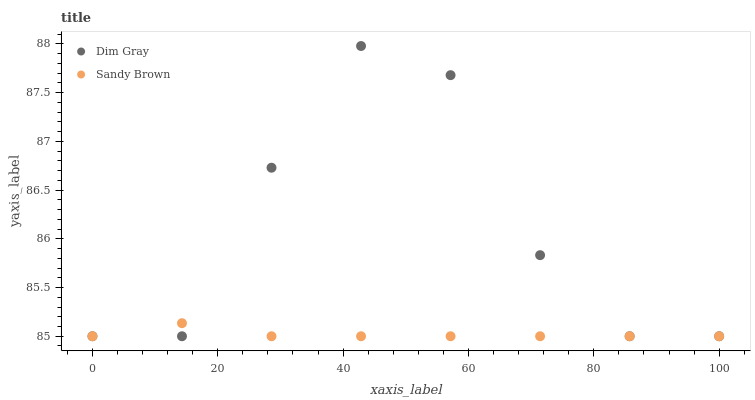Does Sandy Brown have the minimum area under the curve?
Answer yes or no. Yes. Does Dim Gray have the maximum area under the curve?
Answer yes or no. Yes. Does Sandy Brown have the maximum area under the curve?
Answer yes or no. No. Is Sandy Brown the smoothest?
Answer yes or no. Yes. Is Dim Gray the roughest?
Answer yes or no. Yes. Is Sandy Brown the roughest?
Answer yes or no. No. Does Dim Gray have the lowest value?
Answer yes or no. Yes. Does Dim Gray have the highest value?
Answer yes or no. Yes. Does Sandy Brown have the highest value?
Answer yes or no. No. Does Dim Gray intersect Sandy Brown?
Answer yes or no. Yes. Is Dim Gray less than Sandy Brown?
Answer yes or no. No. Is Dim Gray greater than Sandy Brown?
Answer yes or no. No. 